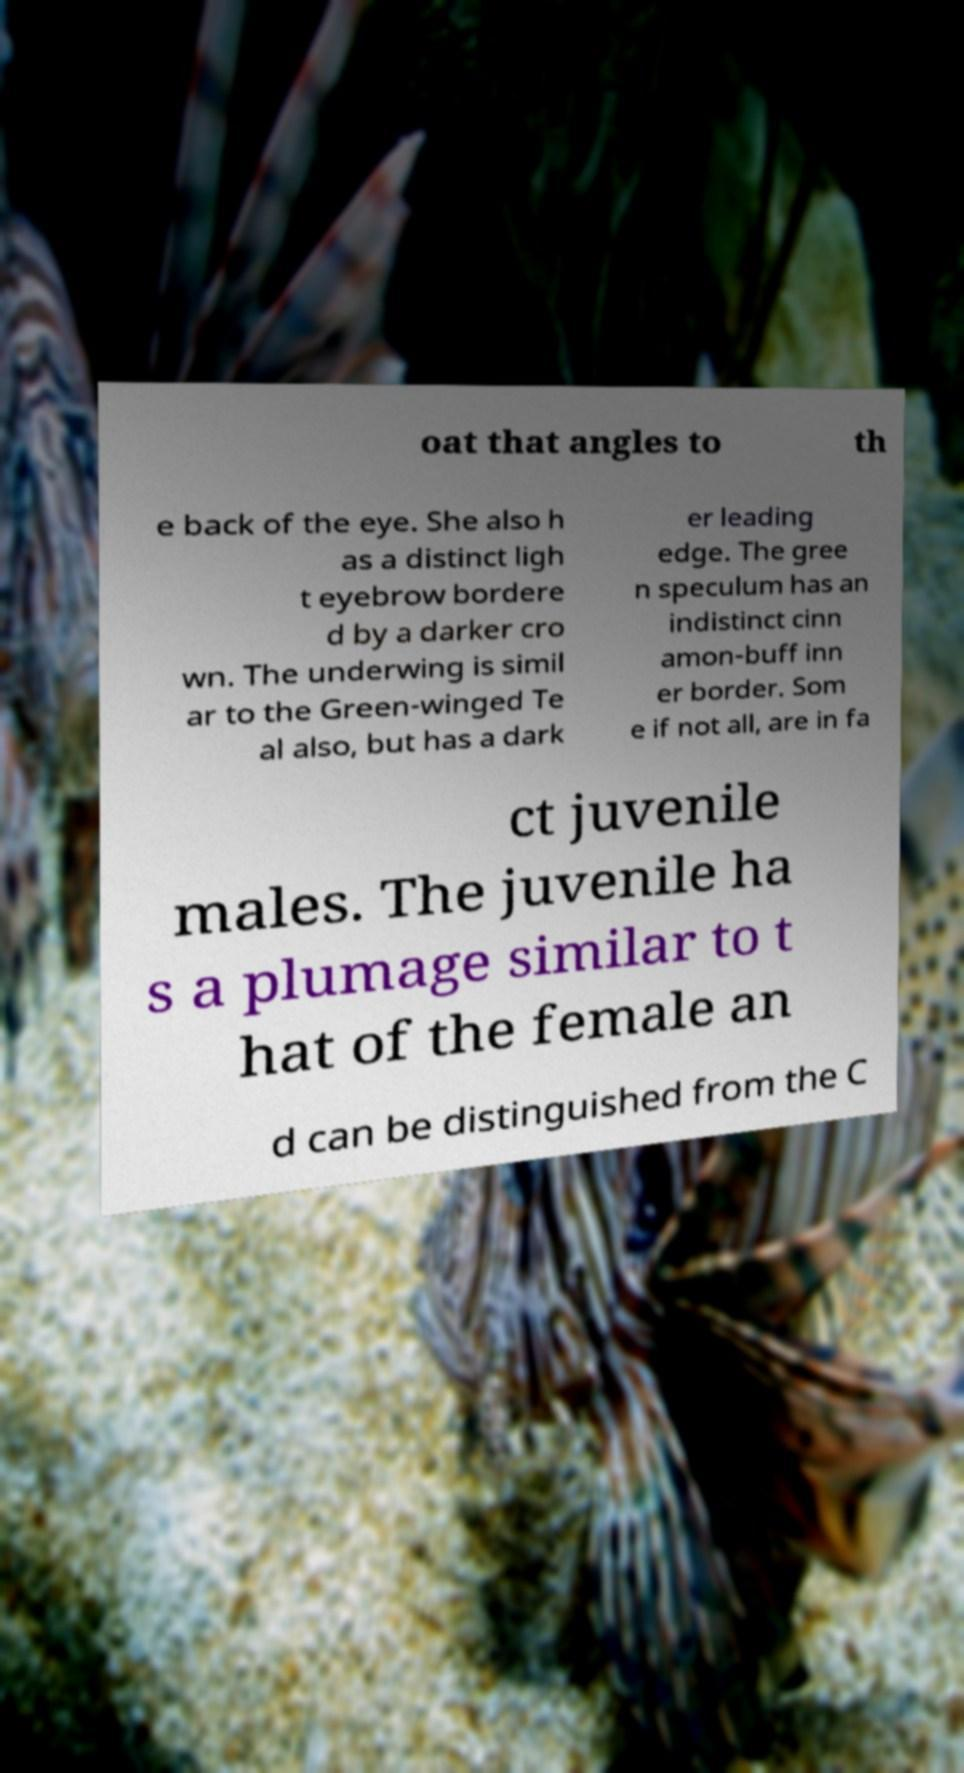There's text embedded in this image that I need extracted. Can you transcribe it verbatim? oat that angles to th e back of the eye. She also h as a distinct ligh t eyebrow bordere d by a darker cro wn. The underwing is simil ar to the Green-winged Te al also, but has a dark er leading edge. The gree n speculum has an indistinct cinn amon-buff inn er border. Som e if not all, are in fa ct juvenile males. The juvenile ha s a plumage similar to t hat of the female an d can be distinguished from the C 